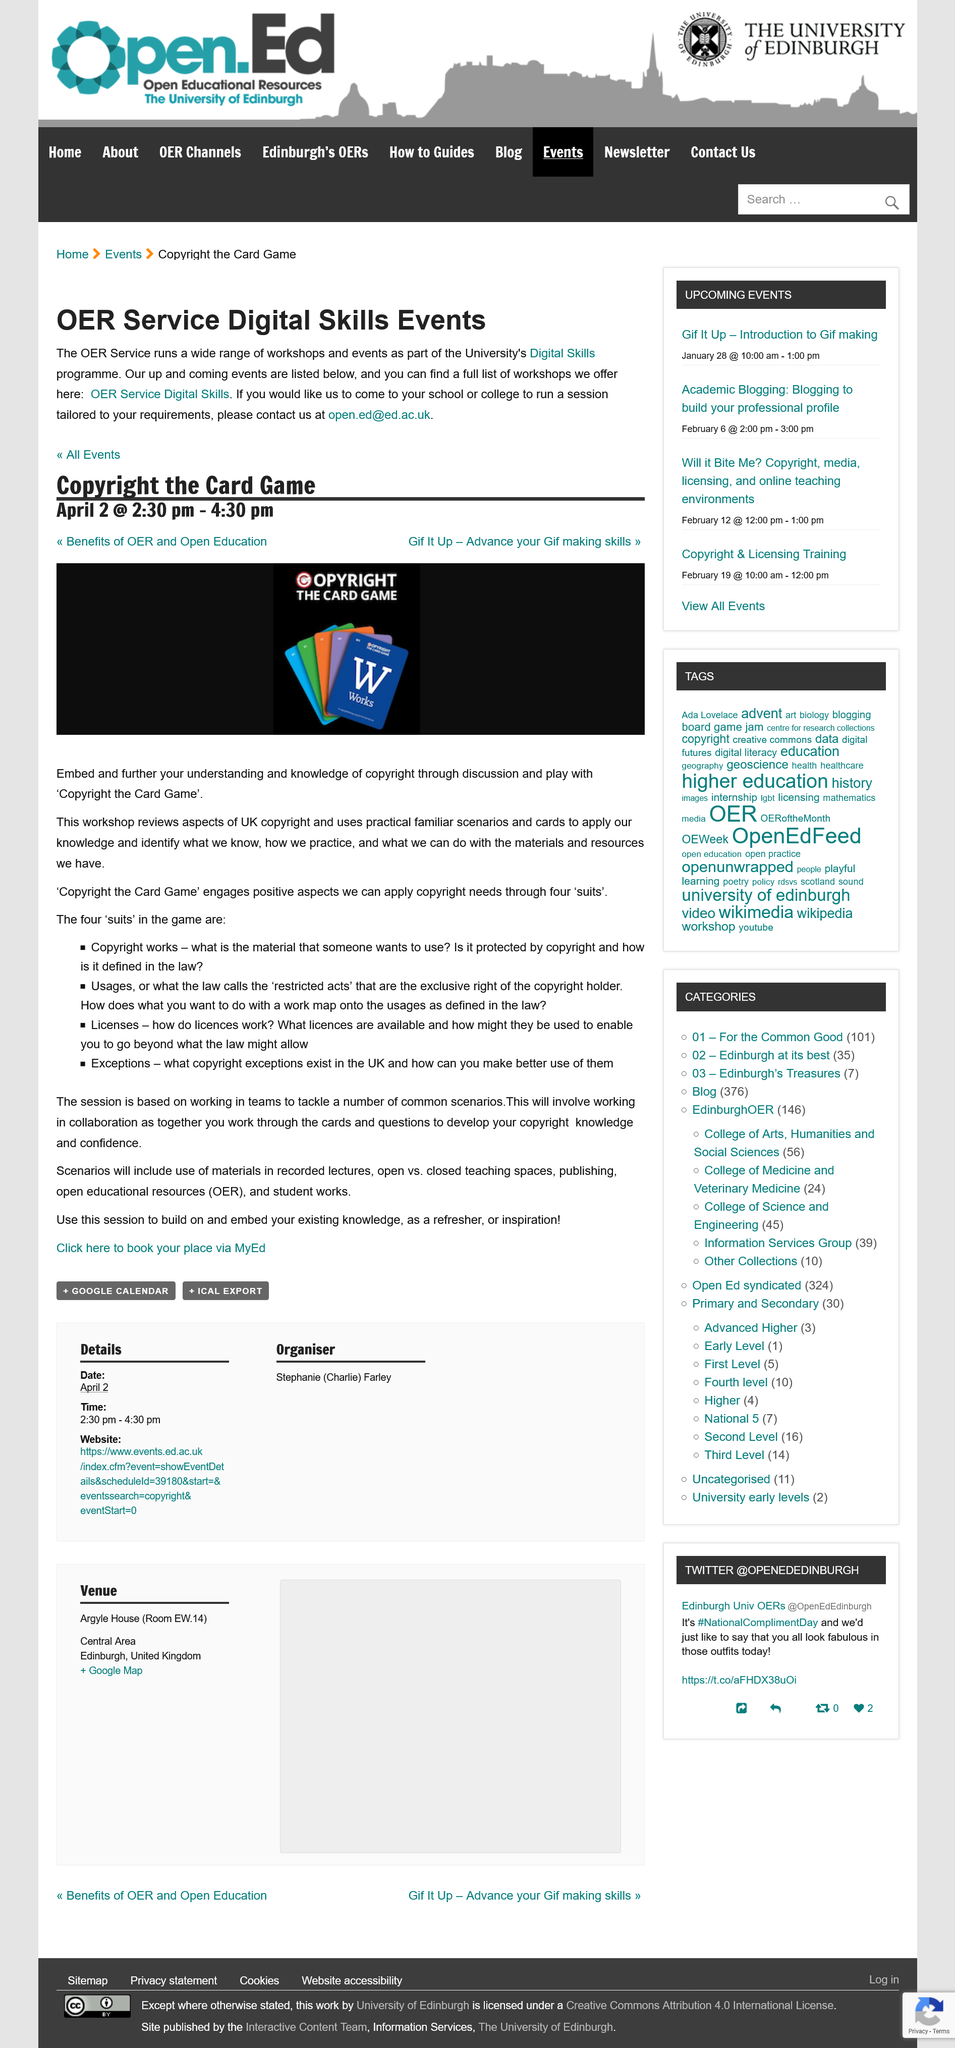Mention a couple of crucial points in this snapshot. The event is scheduled to take place between the hours of 2:30 pm and 4:30 pm. I observed that the card at the front of the deck with the letter 'W' on it is blue in color. According to the page "OER Service Digital Skills Events," the event "Copyright the Card Game" is taking place on April 2nd. 